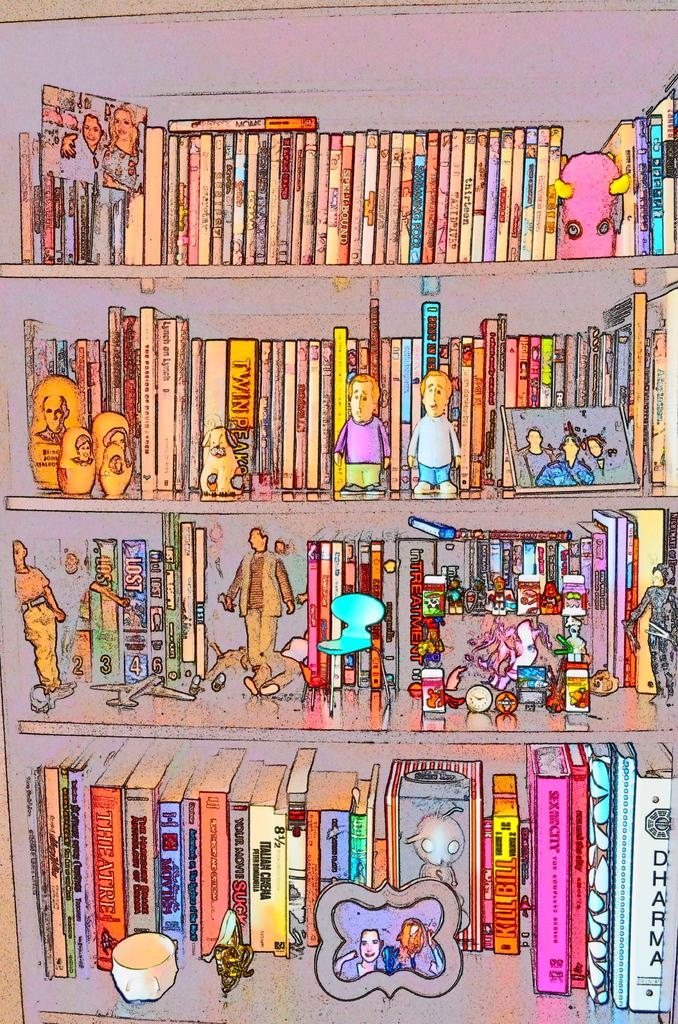<image>
Create a compact narrative representing the image presented. an abstract of a children's book shelf with titles like Dharma 